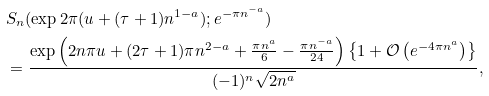<formula> <loc_0><loc_0><loc_500><loc_500>& S _ { n } ( \exp 2 \pi ( u + ( \tau + 1 ) n ^ { 1 - a } ) ; e ^ { - \pi n ^ { - a } } ) \\ & = \frac { \exp \left ( 2 n \pi u + ( 2 \tau + 1 ) \pi n ^ { 2 - a } + \frac { \pi n ^ { a } } { 6 } - \frac { \pi n ^ { - a } } { 2 4 } \right ) \left \{ 1 + \mathcal { O } \left ( e ^ { - 4 \pi n ^ { a } } \right ) \right \} } { ( - 1 ) ^ { n } \sqrt { 2 n ^ { a } } } ,</formula> 